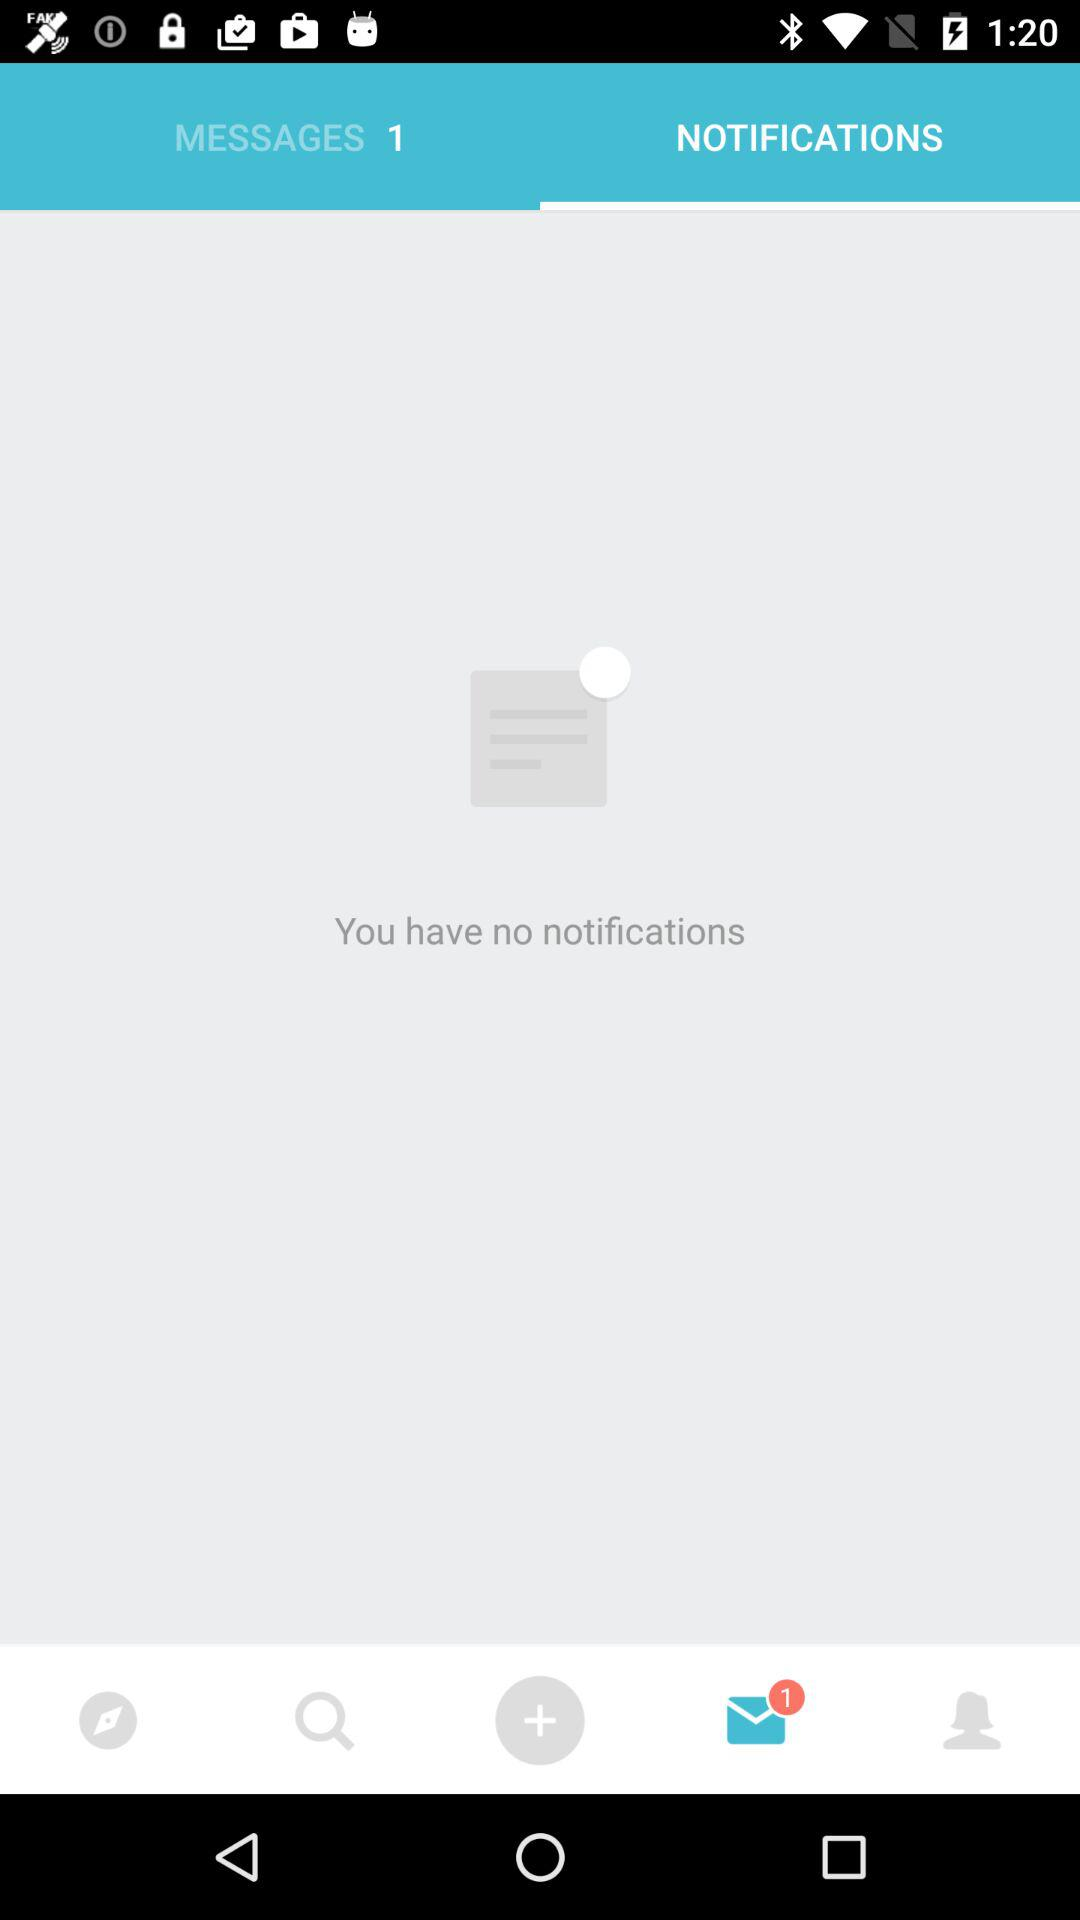Which tab is selected? The selected tabs are "NOTIFICATIONS" and "Messages". 